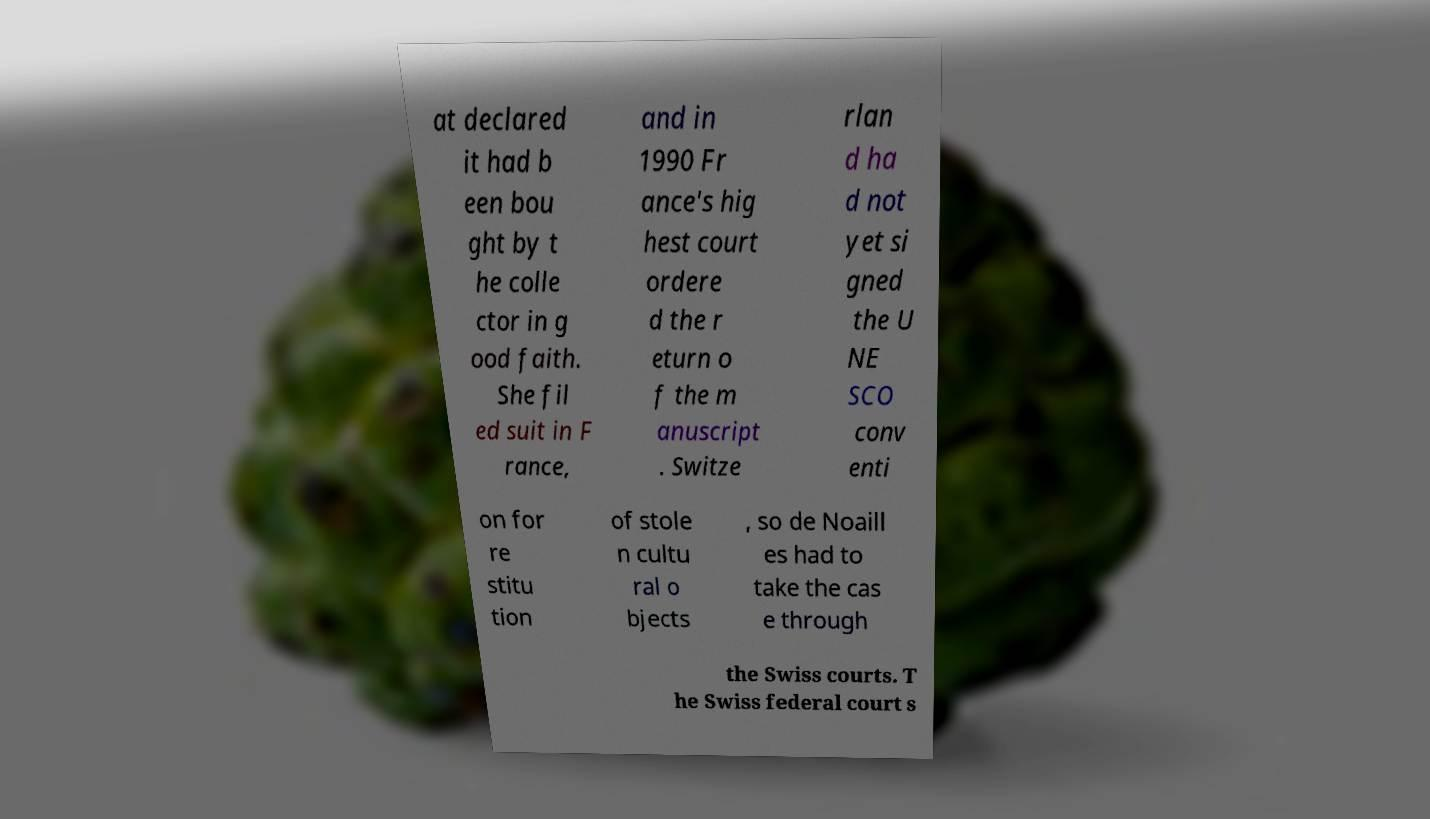I need the written content from this picture converted into text. Can you do that? at declared it had b een bou ght by t he colle ctor in g ood faith. She fil ed suit in F rance, and in 1990 Fr ance's hig hest court ordere d the r eturn o f the m anuscript . Switze rlan d ha d not yet si gned the U NE SCO conv enti on for re stitu tion of stole n cultu ral o bjects , so de Noaill es had to take the cas e through the Swiss courts. T he Swiss federal court s 